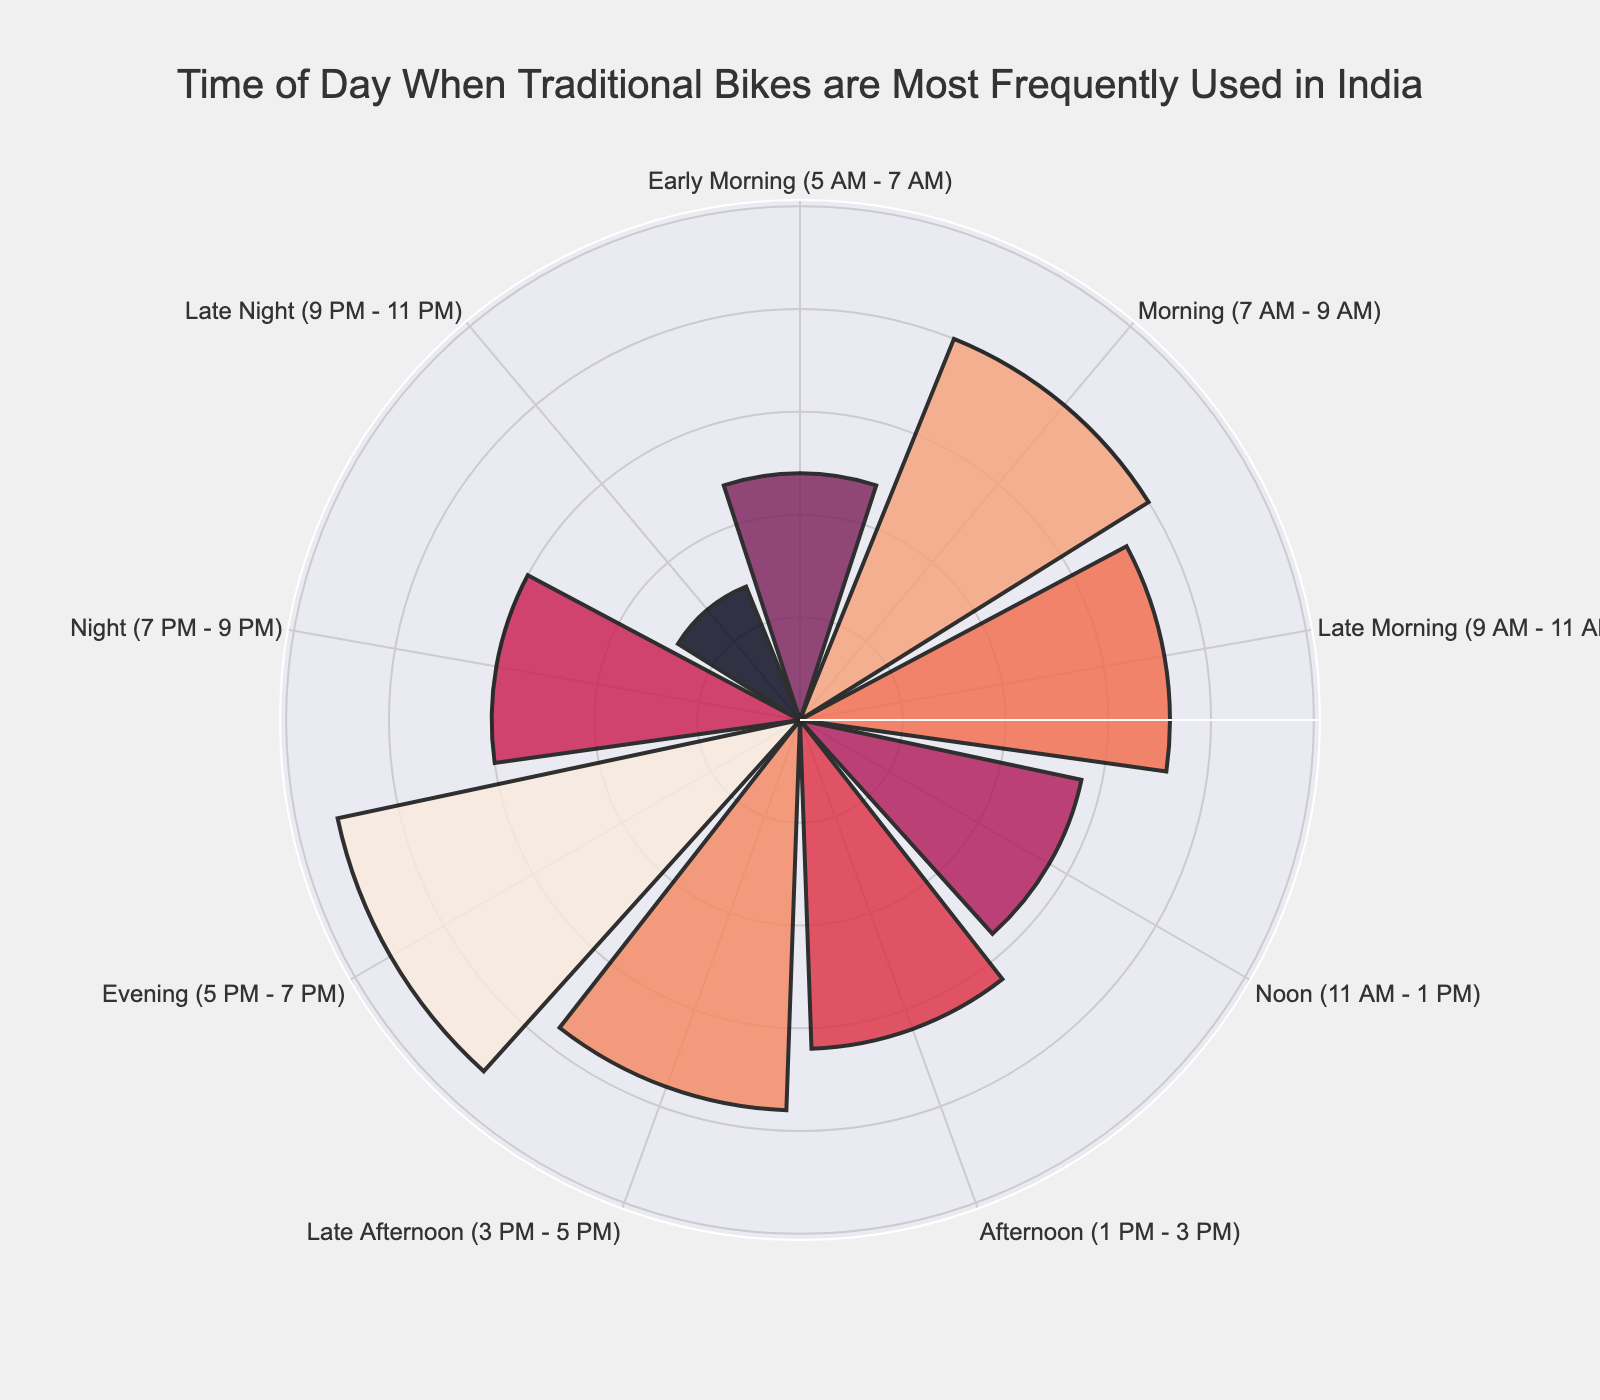What is the title of the figure? The title is usually located at the top center of the figure. It provides a concise description of what the figure represents.
Answer: Time of Day When Traditional Bikes are Most Frequently Used in India At what time of day is the frequency of traditional bike usage the highest? Identify the bar with the maximum radial length (highest value). In this case, it's the "Evening (5 PM - 7 PM)" segment.
Answer: Evening (5 PM - 7 PM) What is the frequency of bike usage in the Early Morning (5 AM - 7 AM) slot? Locate the Early Morning segment and read its radial value, which represents the frequency of bike usage.
Answer: 120 Which time slot has the lowest frequency of bike usage, and what is that frequency? Find the bar with the smallest radial length. This segment is "Late Night (9 PM - 11 PM)" with 70.
Answer: Late Night (9 PM - 11 PM), 70 Compare the bike usage in the Morning (7 AM - 9 AM) to the Afternoon (1 PM - 3 PM). Which one is higher and by how much? Compare the radial values of both segments. Morning has a frequency of 200, while Afternoon has 160. The difference is 200-160.
Answer: Morning (7 AM - 9 AM) is higher by 40 What is the total frequency of traditional bike usage from Early Morning (5 AM) to Late Morning (11 AM)? Sum the radial values for Early Morning, Morning, and Late Morning segments: 120 + 200 + 180 = 500.
Answer: 500 Which two consecutive time slots have the greatest difference in bike usage frequency? Calculate the differences between each pair of consecutive segments and find the maximum difference. The greatest difference is between Evening (230) and Night (150): 230 - 150 = 80.
Answer: Evening (5 PM - 7 PM) & Night (7 PM - 9 PM), difference of 80 What is the average frequency of bike usage during daytime hours (7 AM to 7 PM)? Identify the relevant segments (Morning, Late Morning, Noon, Afternoon, Late Afternoon, Evening) and calculate the average: (200 + 180 + 140 + 160 + 190 + 230) / 6 = 180.
Answer: 180 How does bike usage during the Late Afternoon (3 PM - 5 PM) compare to that at Night (7 PM - 9 PM)? Compare the radial values of the Late Afternoon and Night segments. Late Afternoon has 190 and Night has 150.
Answer: Late Afternoon (3 PM - 5 PM) is higher by 40 